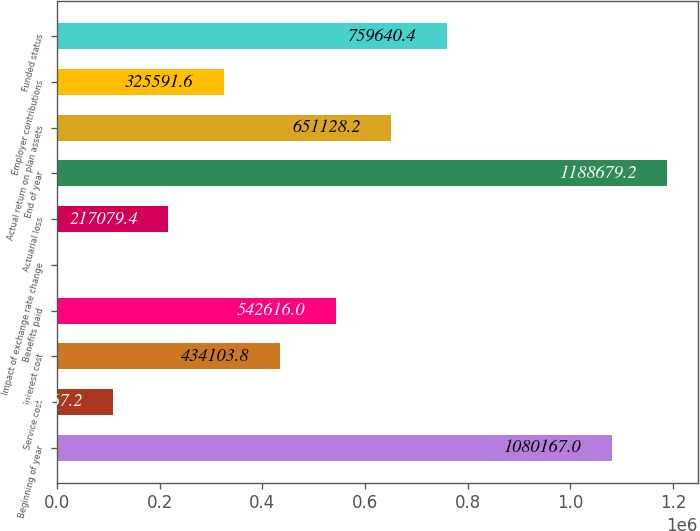<chart> <loc_0><loc_0><loc_500><loc_500><bar_chart><fcel>Beginning of year<fcel>Service cost<fcel>Interest cost<fcel>Benefits paid<fcel>Impact of exchange rate change<fcel>Actuarial loss<fcel>End of year<fcel>Actual return on plan assets<fcel>Employer contributions<fcel>Funded status<nl><fcel>1.08017e+06<fcel>108567<fcel>434104<fcel>542616<fcel>55<fcel>217079<fcel>1.18868e+06<fcel>651128<fcel>325592<fcel>759640<nl></chart> 